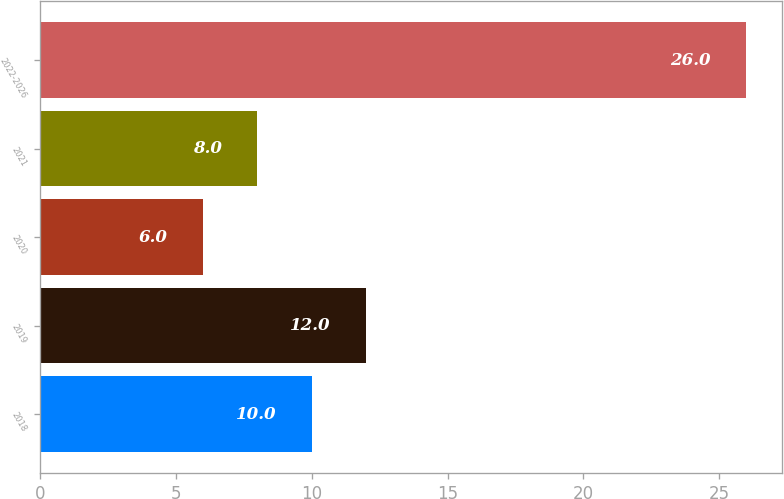Convert chart. <chart><loc_0><loc_0><loc_500><loc_500><bar_chart><fcel>2018<fcel>2019<fcel>2020<fcel>2021<fcel>2022-2026<nl><fcel>10<fcel>12<fcel>6<fcel>8<fcel>26<nl></chart> 